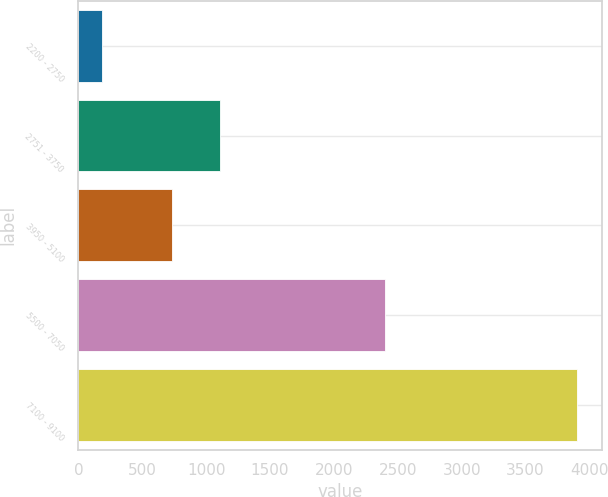<chart> <loc_0><loc_0><loc_500><loc_500><bar_chart><fcel>2200 - 2750<fcel>2751 - 3750<fcel>3950 - 5100<fcel>5500 - 7050<fcel>7100 - 9100<nl><fcel>187<fcel>1105.3<fcel>734<fcel>2403<fcel>3900<nl></chart> 